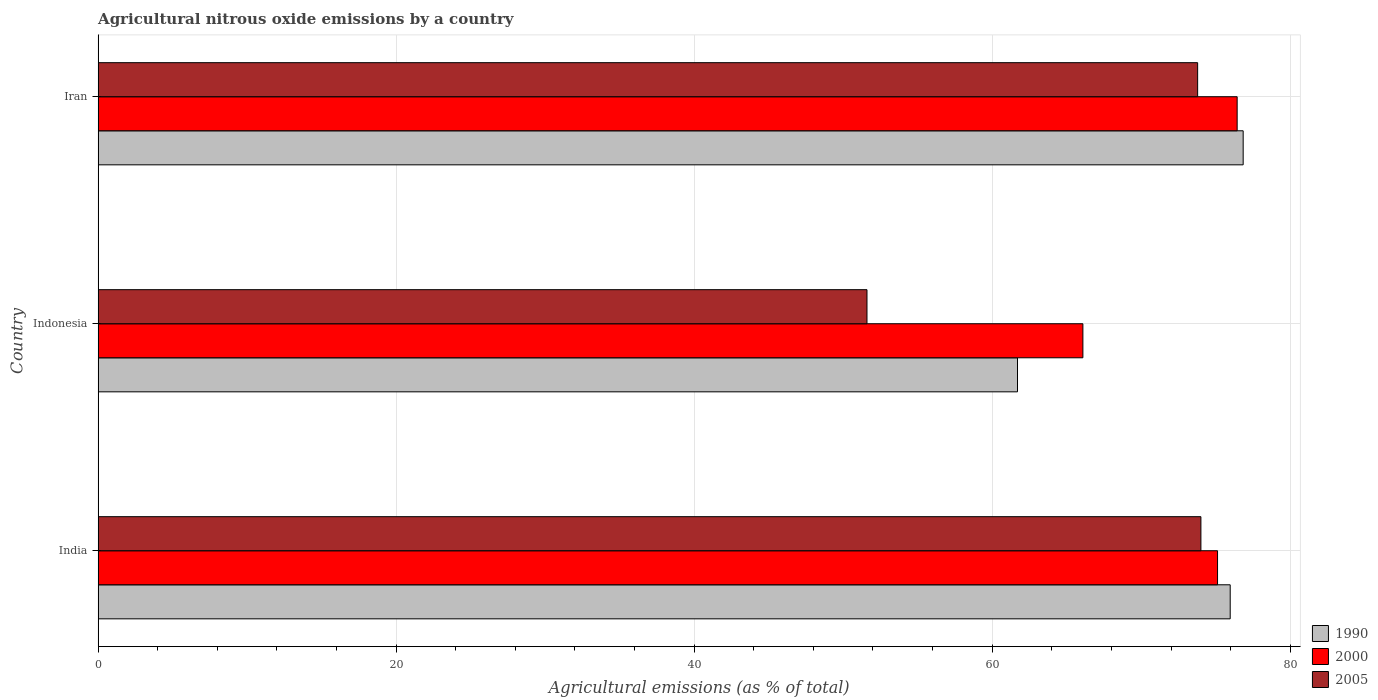How many different coloured bars are there?
Your answer should be very brief. 3. How many bars are there on the 2nd tick from the top?
Make the answer very short. 3. What is the label of the 1st group of bars from the top?
Provide a succinct answer. Iran. What is the amount of agricultural nitrous oxide emitted in 2005 in Iran?
Ensure brevity in your answer.  73.79. Across all countries, what is the maximum amount of agricultural nitrous oxide emitted in 2000?
Ensure brevity in your answer.  76.44. Across all countries, what is the minimum amount of agricultural nitrous oxide emitted in 2000?
Ensure brevity in your answer.  66.09. In which country was the amount of agricultural nitrous oxide emitted in 2000 maximum?
Offer a very short reply. Iran. What is the total amount of agricultural nitrous oxide emitted in 1990 in the graph?
Give a very brief answer. 214.52. What is the difference between the amount of agricultural nitrous oxide emitted in 2000 in India and that in Indonesia?
Ensure brevity in your answer.  9.04. What is the difference between the amount of agricultural nitrous oxide emitted in 2005 in India and the amount of agricultural nitrous oxide emitted in 1990 in Indonesia?
Your response must be concise. 12.31. What is the average amount of agricultural nitrous oxide emitted in 2005 per country?
Provide a short and direct response. 66.46. What is the difference between the amount of agricultural nitrous oxide emitted in 2000 and amount of agricultural nitrous oxide emitted in 2005 in India?
Offer a very short reply. 1.12. In how many countries, is the amount of agricultural nitrous oxide emitted in 1990 greater than 64 %?
Make the answer very short. 2. What is the ratio of the amount of agricultural nitrous oxide emitted in 1990 in India to that in Indonesia?
Make the answer very short. 1.23. What is the difference between the highest and the second highest amount of agricultural nitrous oxide emitted in 1990?
Ensure brevity in your answer.  0.87. What is the difference between the highest and the lowest amount of agricultural nitrous oxide emitted in 2005?
Your response must be concise. 22.41. In how many countries, is the amount of agricultural nitrous oxide emitted in 2005 greater than the average amount of agricultural nitrous oxide emitted in 2005 taken over all countries?
Provide a short and direct response. 2. What does the 3rd bar from the top in Indonesia represents?
Your response must be concise. 1990. What does the 2nd bar from the bottom in India represents?
Give a very brief answer. 2000. Is it the case that in every country, the sum of the amount of agricultural nitrous oxide emitted in 2005 and amount of agricultural nitrous oxide emitted in 1990 is greater than the amount of agricultural nitrous oxide emitted in 2000?
Your answer should be compact. Yes. How many bars are there?
Provide a short and direct response. 9. Are all the bars in the graph horizontal?
Give a very brief answer. Yes. How many countries are there in the graph?
Give a very brief answer. 3. Where does the legend appear in the graph?
Offer a very short reply. Bottom right. What is the title of the graph?
Keep it short and to the point. Agricultural nitrous oxide emissions by a country. What is the label or title of the X-axis?
Provide a short and direct response. Agricultural emissions (as % of total). What is the label or title of the Y-axis?
Give a very brief answer. Country. What is the Agricultural emissions (as % of total) of 1990 in India?
Ensure brevity in your answer.  75.97. What is the Agricultural emissions (as % of total) of 2000 in India?
Provide a succinct answer. 75.12. What is the Agricultural emissions (as % of total) of 2005 in India?
Offer a very short reply. 74.01. What is the Agricultural emissions (as % of total) in 1990 in Indonesia?
Your answer should be compact. 61.7. What is the Agricultural emissions (as % of total) in 2000 in Indonesia?
Give a very brief answer. 66.09. What is the Agricultural emissions (as % of total) of 2005 in Indonesia?
Your answer should be compact. 51.6. What is the Agricultural emissions (as % of total) in 1990 in Iran?
Provide a short and direct response. 76.84. What is the Agricultural emissions (as % of total) of 2000 in Iran?
Offer a terse response. 76.44. What is the Agricultural emissions (as % of total) of 2005 in Iran?
Your answer should be compact. 73.79. Across all countries, what is the maximum Agricultural emissions (as % of total) of 1990?
Ensure brevity in your answer.  76.84. Across all countries, what is the maximum Agricultural emissions (as % of total) in 2000?
Your answer should be compact. 76.44. Across all countries, what is the maximum Agricultural emissions (as % of total) in 2005?
Give a very brief answer. 74.01. Across all countries, what is the minimum Agricultural emissions (as % of total) in 1990?
Your answer should be compact. 61.7. Across all countries, what is the minimum Agricultural emissions (as % of total) in 2000?
Offer a terse response. 66.09. Across all countries, what is the minimum Agricultural emissions (as % of total) in 2005?
Keep it short and to the point. 51.6. What is the total Agricultural emissions (as % of total) in 1990 in the graph?
Your answer should be compact. 214.52. What is the total Agricultural emissions (as % of total) of 2000 in the graph?
Provide a succinct answer. 217.65. What is the total Agricultural emissions (as % of total) of 2005 in the graph?
Provide a succinct answer. 199.39. What is the difference between the Agricultural emissions (as % of total) in 1990 in India and that in Indonesia?
Make the answer very short. 14.27. What is the difference between the Agricultural emissions (as % of total) in 2000 in India and that in Indonesia?
Your answer should be compact. 9.04. What is the difference between the Agricultural emissions (as % of total) in 2005 in India and that in Indonesia?
Offer a very short reply. 22.41. What is the difference between the Agricultural emissions (as % of total) of 1990 in India and that in Iran?
Provide a succinct answer. -0.87. What is the difference between the Agricultural emissions (as % of total) of 2000 in India and that in Iran?
Offer a terse response. -1.32. What is the difference between the Agricultural emissions (as % of total) in 2005 in India and that in Iran?
Ensure brevity in your answer.  0.22. What is the difference between the Agricultural emissions (as % of total) in 1990 in Indonesia and that in Iran?
Make the answer very short. -15.14. What is the difference between the Agricultural emissions (as % of total) in 2000 in Indonesia and that in Iran?
Offer a terse response. -10.35. What is the difference between the Agricultural emissions (as % of total) in 2005 in Indonesia and that in Iran?
Your response must be concise. -22.19. What is the difference between the Agricultural emissions (as % of total) of 1990 in India and the Agricultural emissions (as % of total) of 2000 in Indonesia?
Offer a very short reply. 9.89. What is the difference between the Agricultural emissions (as % of total) in 1990 in India and the Agricultural emissions (as % of total) in 2005 in Indonesia?
Provide a short and direct response. 24.38. What is the difference between the Agricultural emissions (as % of total) in 2000 in India and the Agricultural emissions (as % of total) in 2005 in Indonesia?
Offer a very short reply. 23.53. What is the difference between the Agricultural emissions (as % of total) in 1990 in India and the Agricultural emissions (as % of total) in 2000 in Iran?
Your answer should be compact. -0.47. What is the difference between the Agricultural emissions (as % of total) of 1990 in India and the Agricultural emissions (as % of total) of 2005 in Iran?
Give a very brief answer. 2.18. What is the difference between the Agricultural emissions (as % of total) in 2000 in India and the Agricultural emissions (as % of total) in 2005 in Iran?
Offer a very short reply. 1.34. What is the difference between the Agricultural emissions (as % of total) of 1990 in Indonesia and the Agricultural emissions (as % of total) of 2000 in Iran?
Give a very brief answer. -14.74. What is the difference between the Agricultural emissions (as % of total) of 1990 in Indonesia and the Agricultural emissions (as % of total) of 2005 in Iran?
Provide a succinct answer. -12.09. What is the difference between the Agricultural emissions (as % of total) of 2000 in Indonesia and the Agricultural emissions (as % of total) of 2005 in Iran?
Your response must be concise. -7.7. What is the average Agricultural emissions (as % of total) in 1990 per country?
Offer a terse response. 71.51. What is the average Agricultural emissions (as % of total) of 2000 per country?
Provide a succinct answer. 72.55. What is the average Agricultural emissions (as % of total) of 2005 per country?
Your answer should be very brief. 66.46. What is the difference between the Agricultural emissions (as % of total) of 1990 and Agricultural emissions (as % of total) of 2000 in India?
Make the answer very short. 0.85. What is the difference between the Agricultural emissions (as % of total) in 1990 and Agricultural emissions (as % of total) in 2005 in India?
Your answer should be compact. 1.97. What is the difference between the Agricultural emissions (as % of total) of 2000 and Agricultural emissions (as % of total) of 2005 in India?
Provide a succinct answer. 1.12. What is the difference between the Agricultural emissions (as % of total) of 1990 and Agricultural emissions (as % of total) of 2000 in Indonesia?
Your answer should be very brief. -4.39. What is the difference between the Agricultural emissions (as % of total) in 1990 and Agricultural emissions (as % of total) in 2005 in Indonesia?
Offer a very short reply. 10.1. What is the difference between the Agricultural emissions (as % of total) of 2000 and Agricultural emissions (as % of total) of 2005 in Indonesia?
Your answer should be very brief. 14.49. What is the difference between the Agricultural emissions (as % of total) of 1990 and Agricultural emissions (as % of total) of 2000 in Iran?
Ensure brevity in your answer.  0.4. What is the difference between the Agricultural emissions (as % of total) in 1990 and Agricultural emissions (as % of total) in 2005 in Iran?
Provide a succinct answer. 3.06. What is the difference between the Agricultural emissions (as % of total) in 2000 and Agricultural emissions (as % of total) in 2005 in Iran?
Your response must be concise. 2.65. What is the ratio of the Agricultural emissions (as % of total) of 1990 in India to that in Indonesia?
Give a very brief answer. 1.23. What is the ratio of the Agricultural emissions (as % of total) of 2000 in India to that in Indonesia?
Your answer should be very brief. 1.14. What is the ratio of the Agricultural emissions (as % of total) in 2005 in India to that in Indonesia?
Keep it short and to the point. 1.43. What is the ratio of the Agricultural emissions (as % of total) in 1990 in India to that in Iran?
Your answer should be compact. 0.99. What is the ratio of the Agricultural emissions (as % of total) in 2000 in India to that in Iran?
Keep it short and to the point. 0.98. What is the ratio of the Agricultural emissions (as % of total) of 1990 in Indonesia to that in Iran?
Offer a terse response. 0.8. What is the ratio of the Agricultural emissions (as % of total) in 2000 in Indonesia to that in Iran?
Give a very brief answer. 0.86. What is the ratio of the Agricultural emissions (as % of total) in 2005 in Indonesia to that in Iran?
Your answer should be very brief. 0.7. What is the difference between the highest and the second highest Agricultural emissions (as % of total) of 1990?
Your answer should be compact. 0.87. What is the difference between the highest and the second highest Agricultural emissions (as % of total) of 2000?
Make the answer very short. 1.32. What is the difference between the highest and the second highest Agricultural emissions (as % of total) in 2005?
Offer a terse response. 0.22. What is the difference between the highest and the lowest Agricultural emissions (as % of total) in 1990?
Make the answer very short. 15.14. What is the difference between the highest and the lowest Agricultural emissions (as % of total) of 2000?
Offer a terse response. 10.35. What is the difference between the highest and the lowest Agricultural emissions (as % of total) in 2005?
Make the answer very short. 22.41. 